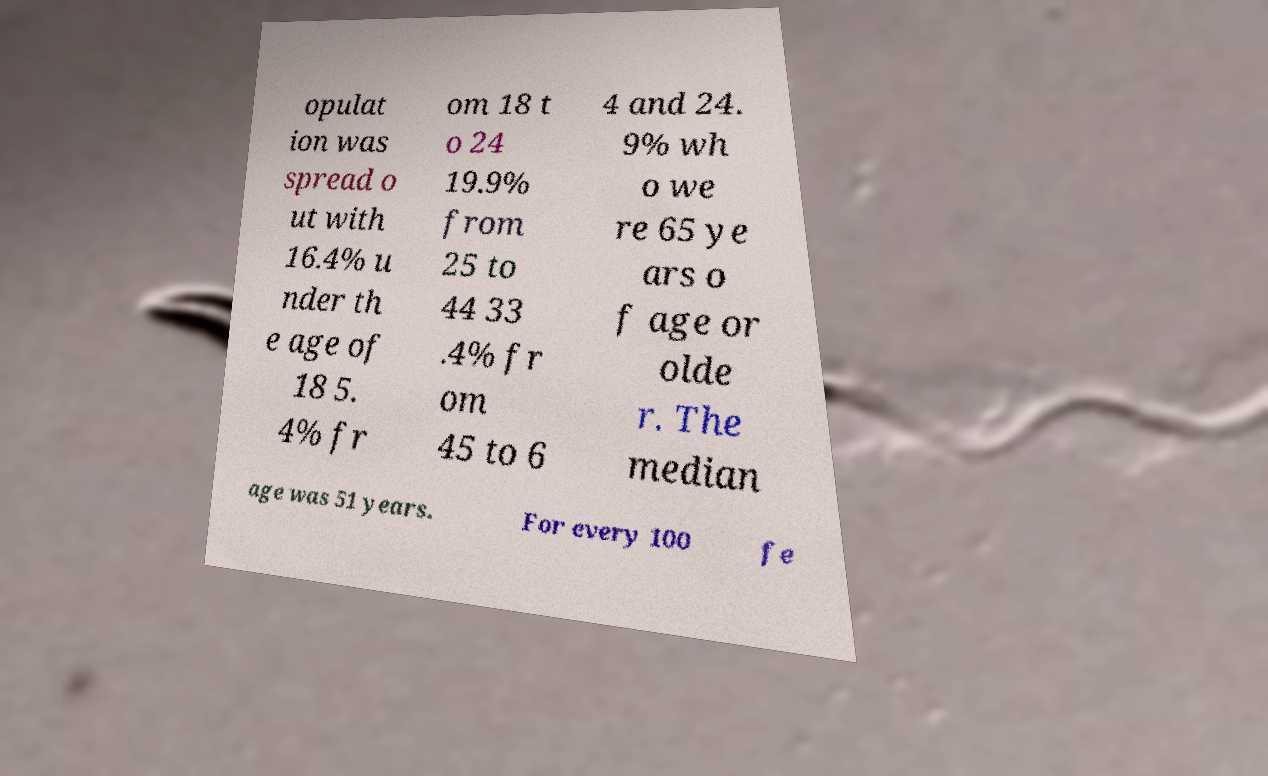Can you accurately transcribe the text from the provided image for me? opulat ion was spread o ut with 16.4% u nder th e age of 18 5. 4% fr om 18 t o 24 19.9% from 25 to 44 33 .4% fr om 45 to 6 4 and 24. 9% wh o we re 65 ye ars o f age or olde r. The median age was 51 years. For every 100 fe 